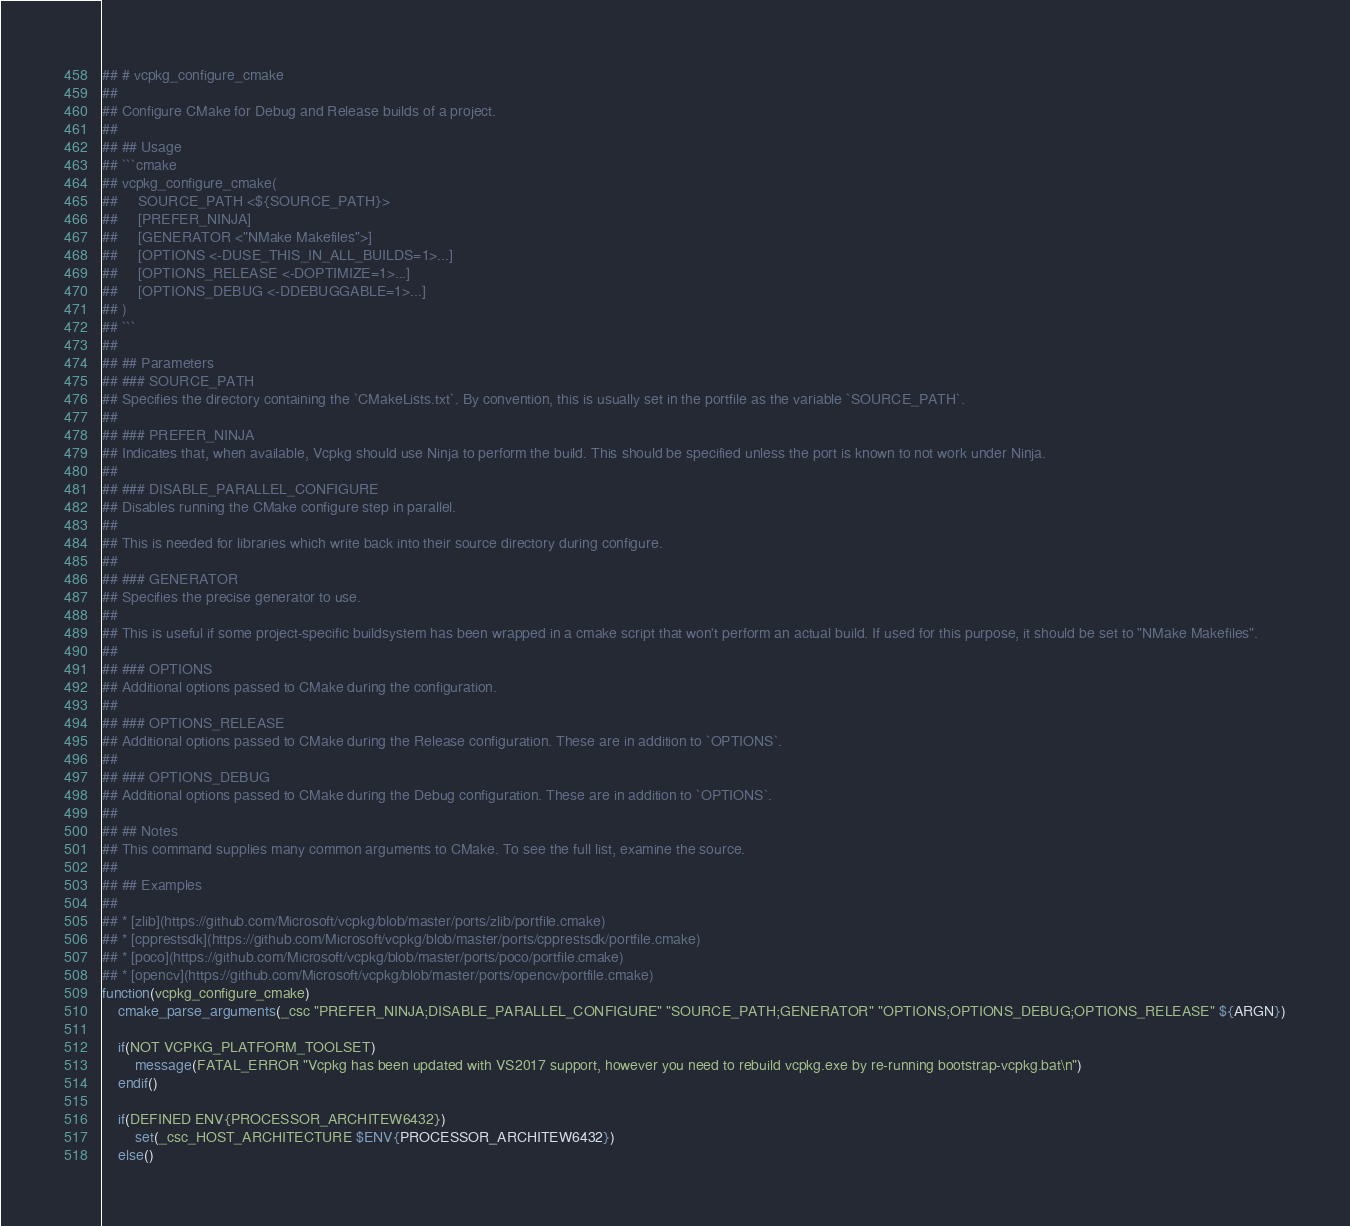<code> <loc_0><loc_0><loc_500><loc_500><_CMake_>## # vcpkg_configure_cmake
##
## Configure CMake for Debug and Release builds of a project.
##
## ## Usage
## ```cmake
## vcpkg_configure_cmake(
##     SOURCE_PATH <${SOURCE_PATH}>
##     [PREFER_NINJA]
##     [GENERATOR <"NMake Makefiles">]
##     [OPTIONS <-DUSE_THIS_IN_ALL_BUILDS=1>...]
##     [OPTIONS_RELEASE <-DOPTIMIZE=1>...]
##     [OPTIONS_DEBUG <-DDEBUGGABLE=1>...]
## )
## ```
##
## ## Parameters
## ### SOURCE_PATH
## Specifies the directory containing the `CMakeLists.txt`. By convention, this is usually set in the portfile as the variable `SOURCE_PATH`.
##
## ### PREFER_NINJA
## Indicates that, when available, Vcpkg should use Ninja to perform the build. This should be specified unless the port is known to not work under Ninja.
##
## ### DISABLE_PARALLEL_CONFIGURE
## Disables running the CMake configure step in parallel.
##
## This is needed for libraries which write back into their source directory during configure.
##
## ### GENERATOR
## Specifies the precise generator to use.
##
## This is useful if some project-specific buildsystem has been wrapped in a cmake script that won't perform an actual build. If used for this purpose, it should be set to "NMake Makefiles".
##
## ### OPTIONS
## Additional options passed to CMake during the configuration.
##
## ### OPTIONS_RELEASE
## Additional options passed to CMake during the Release configuration. These are in addition to `OPTIONS`.
##
## ### OPTIONS_DEBUG
## Additional options passed to CMake during the Debug configuration. These are in addition to `OPTIONS`.
##
## ## Notes
## This command supplies many common arguments to CMake. To see the full list, examine the source.
##
## ## Examples
##
## * [zlib](https://github.com/Microsoft/vcpkg/blob/master/ports/zlib/portfile.cmake)
## * [cpprestsdk](https://github.com/Microsoft/vcpkg/blob/master/ports/cpprestsdk/portfile.cmake)
## * [poco](https://github.com/Microsoft/vcpkg/blob/master/ports/poco/portfile.cmake)
## * [opencv](https://github.com/Microsoft/vcpkg/blob/master/ports/opencv/portfile.cmake)
function(vcpkg_configure_cmake)
    cmake_parse_arguments(_csc "PREFER_NINJA;DISABLE_PARALLEL_CONFIGURE" "SOURCE_PATH;GENERATOR" "OPTIONS;OPTIONS_DEBUG;OPTIONS_RELEASE" ${ARGN})

    if(NOT VCPKG_PLATFORM_TOOLSET)
        message(FATAL_ERROR "Vcpkg has been updated with VS2017 support, however you need to rebuild vcpkg.exe by re-running bootstrap-vcpkg.bat\n")
    endif()

    if(DEFINED ENV{PROCESSOR_ARCHITEW6432})
        set(_csc_HOST_ARCHITECTURE $ENV{PROCESSOR_ARCHITEW6432})
    else()</code> 